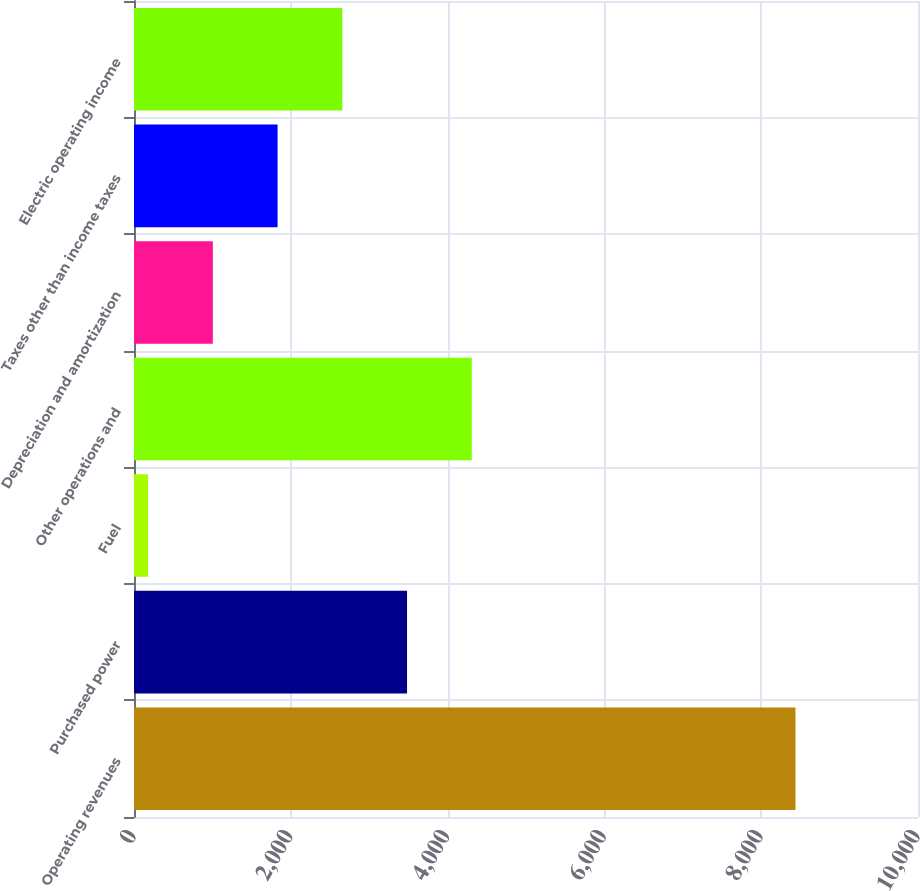Convert chart. <chart><loc_0><loc_0><loc_500><loc_500><bar_chart><fcel>Operating revenues<fcel>Purchased power<fcel>Fuel<fcel>Other operations and<fcel>Depreciation and amortization<fcel>Taxes other than income taxes<fcel>Electric operating income<nl><fcel>8437<fcel>3482.8<fcel>180<fcel>4308.5<fcel>1005.7<fcel>1831.4<fcel>2657.1<nl></chart> 